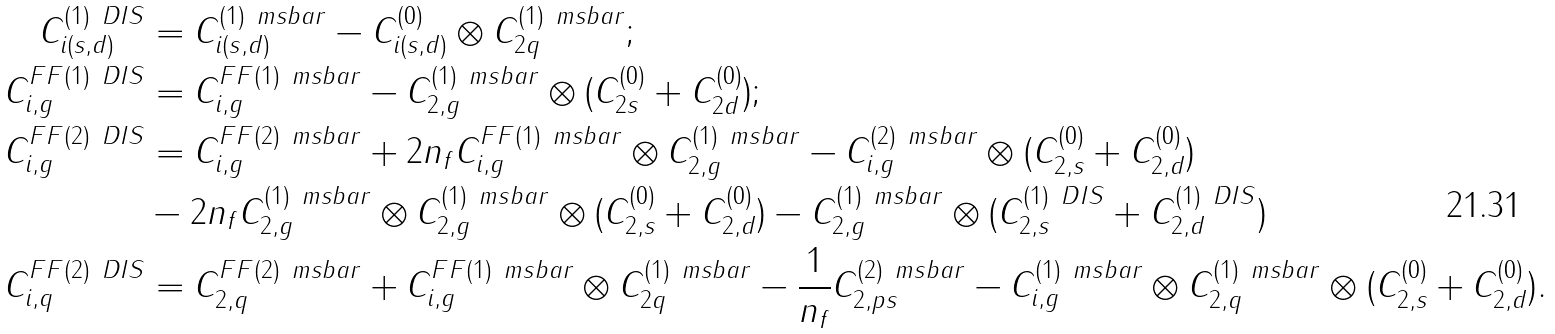Convert formula to latex. <formula><loc_0><loc_0><loc_500><loc_500>C _ { i ( s , d ) } ^ { ( 1 ) \ D I S } & = C _ { i ( s , d ) } ^ { ( 1 ) \ m s b a r } - C _ { i ( s , d ) } ^ { ( 0 ) } \otimes C _ { 2 q } ^ { ( 1 ) \ m s b a r } ; \\ C _ { i , g } ^ { F F ( 1 ) \ D I S } & = C _ { i , g } ^ { F F ( 1 ) \ m s b a r } - C _ { 2 , g } ^ { ( 1 ) \ m s b a r } \otimes ( C _ { 2 s } ^ { ( 0 ) } + C _ { 2 d } ^ { ( 0 ) } ) ; \\ C _ { i , g } ^ { F F ( 2 ) \ D I S } & = C _ { i , g } ^ { F F ( 2 ) \ m s b a r } + 2 n _ { f } C _ { i , g } ^ { F F ( 1 ) \ m s b a r } \otimes C _ { 2 , g } ^ { ( 1 ) \ m s b a r } - C _ { i , g } ^ { ( 2 ) \ m s b a r } \otimes ( C _ { 2 , s } ^ { ( 0 ) } + C _ { 2 , d } ^ { ( 0 ) } ) \\ & - 2 n _ { f } C _ { 2 , g } ^ { ( 1 ) \ m s b a r } \otimes C _ { 2 , g } ^ { ( 1 ) \ m s b a r } \otimes ( C _ { 2 , s } ^ { ( 0 ) } + C _ { 2 , d } ^ { ( 0 ) } ) - C _ { 2 , g } ^ { ( 1 ) \ m s b a r } \otimes ( C _ { 2 , s } ^ { ( 1 ) \ D I S } + C _ { 2 , d } ^ { ( 1 ) \ D I S } ) \\ C _ { i , q } ^ { F F ( 2 ) \ D I S } & = C _ { 2 , q } ^ { F F ( 2 ) \ m s b a r } + C _ { i , g } ^ { F F ( 1 ) \ m s b a r } \otimes C _ { 2 q } ^ { ( 1 ) \ m s b a r } - \frac { 1 } { n _ { f } } C _ { 2 , p s } ^ { ( 2 ) \ m s b a r } - C _ { i , g } ^ { ( 1 ) \ m s b a r } \otimes C _ { 2 , q } ^ { ( 1 ) \ m s b a r } \otimes ( C _ { 2 , s } ^ { ( 0 ) } + C _ { 2 , d } ^ { ( 0 ) } ) .</formula> 